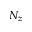Convert formula to latex. <formula><loc_0><loc_0><loc_500><loc_500>N _ { z }</formula> 